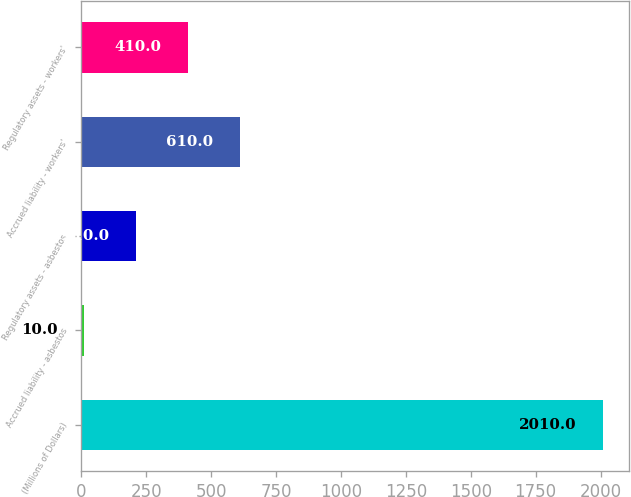Convert chart to OTSL. <chart><loc_0><loc_0><loc_500><loc_500><bar_chart><fcel>(Millions of Dollars)<fcel>Accrued liability - asbestos<fcel>Regulatory assets - asbestos<fcel>Accrued liability - workers'<fcel>Regulatory assets - workers'<nl><fcel>2010<fcel>10<fcel>210<fcel>610<fcel>410<nl></chart> 